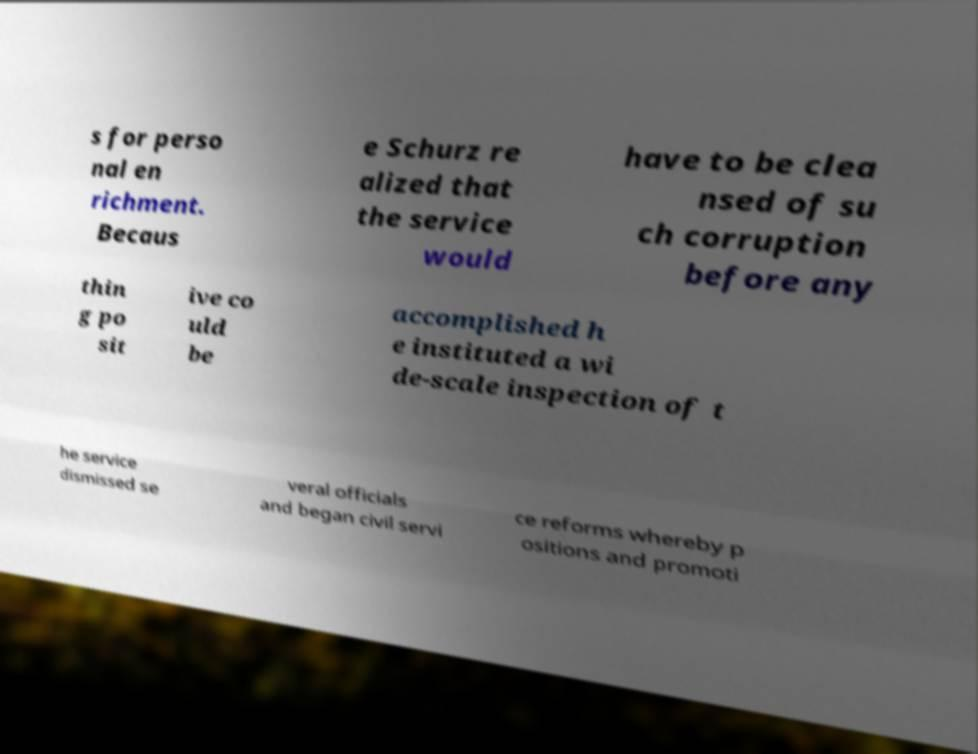Could you extract and type out the text from this image? s for perso nal en richment. Becaus e Schurz re alized that the service would have to be clea nsed of su ch corruption before any thin g po sit ive co uld be accomplished h e instituted a wi de-scale inspection of t he service dismissed se veral officials and began civil servi ce reforms whereby p ositions and promoti 